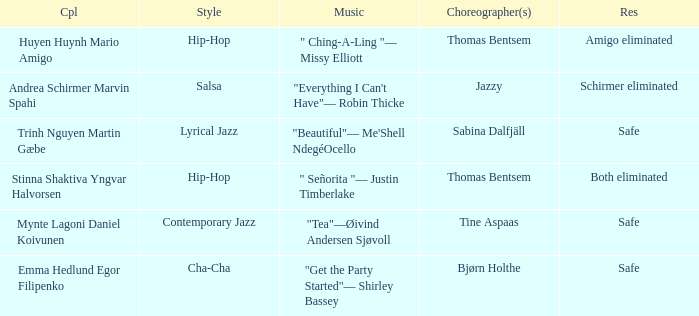What is the result of choreographer bjørn holthe? Safe. 